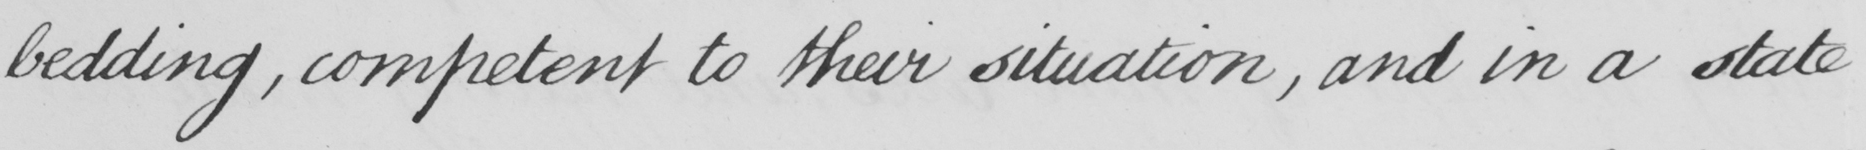What does this handwritten line say? bedding, competent to their situation, and in a state 